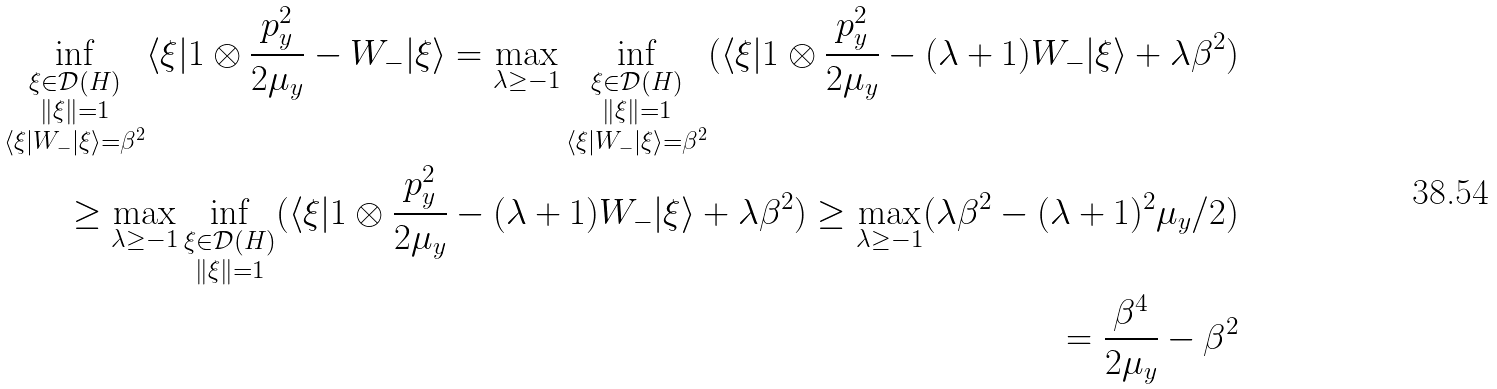<formula> <loc_0><loc_0><loc_500><loc_500>\inf _ { \substack { \xi \in \mathcal { D } ( H ) \\ \| \xi \| = 1 \\ \langle \xi | W _ { - } | \xi \rangle = \beta ^ { 2 } } } \langle \xi | 1 \otimes \frac { p _ { y } ^ { 2 } } { 2 \mu _ { y } } - W _ { - } | \xi \rangle = \max _ { \lambda \geq - 1 } \inf _ { \substack { \xi \in \mathcal { D } ( H ) \\ \| \xi \| = 1 \\ \langle \xi | W _ { - } | \xi \rangle = \beta ^ { 2 } } } ( \langle \xi | 1 \otimes \frac { p _ { y } ^ { 2 } } { 2 \mu _ { y } } - ( \lambda + 1 ) W _ { - } | \xi \rangle + \lambda \beta ^ { 2 } ) \\ \geq \max _ { \lambda \geq - 1 } \inf _ { \substack { \xi \in \mathcal { D } ( H ) \\ \| \xi \| = 1 } } ( \langle \xi | 1 \otimes \frac { p _ { y } ^ { 2 } } { 2 \mu _ { y } } - ( \lambda + 1 ) W _ { - } | \xi \rangle + \lambda \beta ^ { 2 } ) \geq \max _ { \lambda \geq - 1 } ( \lambda \beta ^ { 2 } - ( \lambda + 1 ) ^ { 2 } \mu _ { y } / 2 ) \\ = \frac { \beta ^ { 4 } } { 2 \mu _ { y } } - \beta ^ { 2 }</formula> 